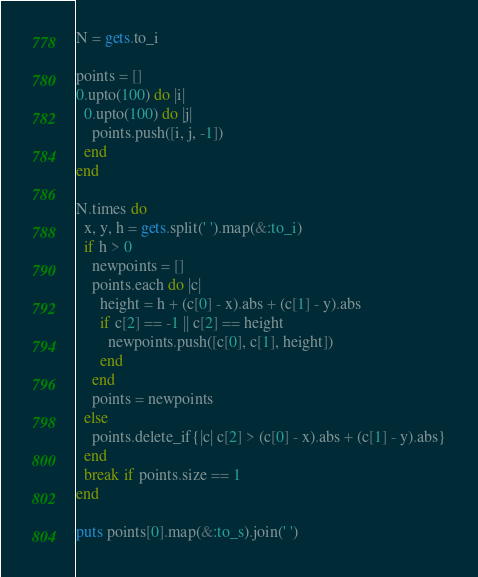Convert code to text. <code><loc_0><loc_0><loc_500><loc_500><_Ruby_>N = gets.to_i

points = []
0.upto(100) do |i|
  0.upto(100) do |j|
    points.push([i, j, -1])
  end
end

N.times do
  x, y, h = gets.split(' ').map(&:to_i)
  if h > 0
    newpoints = []
    points.each do |c|
      height = h + (c[0] - x).abs + (c[1] - y).abs
      if c[2] == -1 || c[2] == height
        newpoints.push([c[0], c[1], height])
      end
    end
    points = newpoints
  else
    points.delete_if{|c| c[2] > (c[0] - x).abs + (c[1] - y).abs}
  end
  break if points.size == 1
end

puts points[0].map(&:to_s).join(' ')</code> 